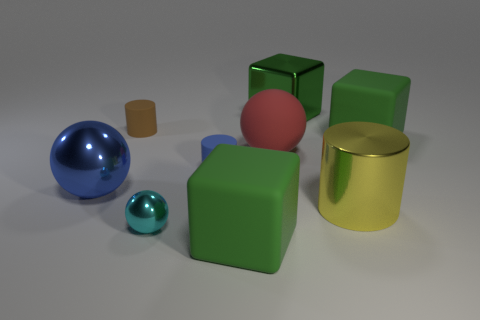What number of metallic things are either tiny purple cubes or tiny spheres?
Offer a very short reply. 1. What is the color of the matte cube behind the big green thing in front of the metal object left of the tiny cyan sphere?
Ensure brevity in your answer.  Green. There is another small matte object that is the same shape as the tiny blue thing; what color is it?
Provide a succinct answer. Brown. Are there any other things of the same color as the metallic cube?
Provide a succinct answer. Yes. How many other things are made of the same material as the big red object?
Provide a succinct answer. 4. The blue matte cylinder is what size?
Offer a very short reply. Small. Are there any other small rubber things of the same shape as the brown rubber object?
Make the answer very short. Yes. How many things are green metallic blocks or objects behind the big metallic ball?
Provide a succinct answer. 5. What color is the shiny sphere that is on the left side of the small brown rubber cylinder?
Provide a short and direct response. Blue. There is a sphere in front of the blue metal ball; is it the same size as the green cube behind the brown rubber cylinder?
Provide a succinct answer. No. 